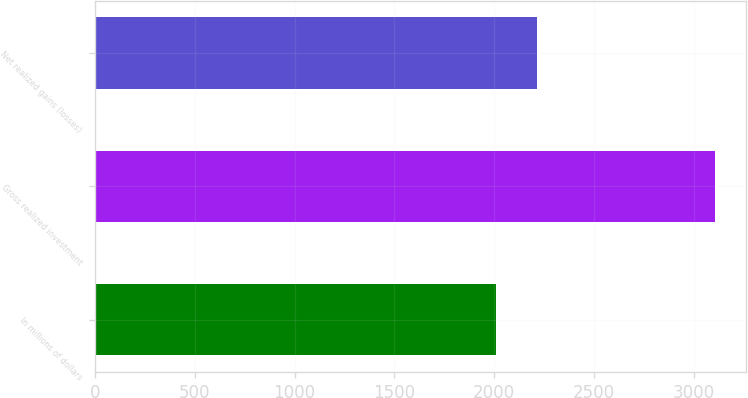Convert chart. <chart><loc_0><loc_0><loc_500><loc_500><bar_chart><fcel>In millions of dollars<fcel>Gross realized investment<fcel>Net realized gains (losses)<nl><fcel>2008<fcel>3105<fcel>2214.1<nl></chart> 